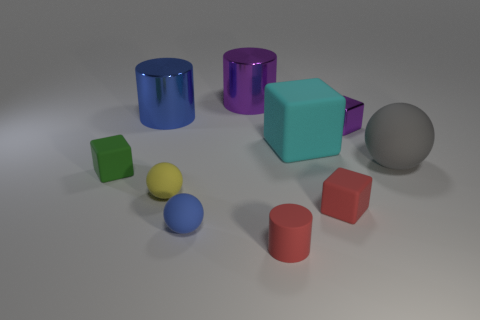Subtract all cylinders. How many objects are left? 7 Subtract 0 green spheres. How many objects are left? 10 Subtract all large blue metallic spheres. Subtract all gray things. How many objects are left? 9 Add 3 matte spheres. How many matte spheres are left? 6 Add 9 yellow blocks. How many yellow blocks exist? 9 